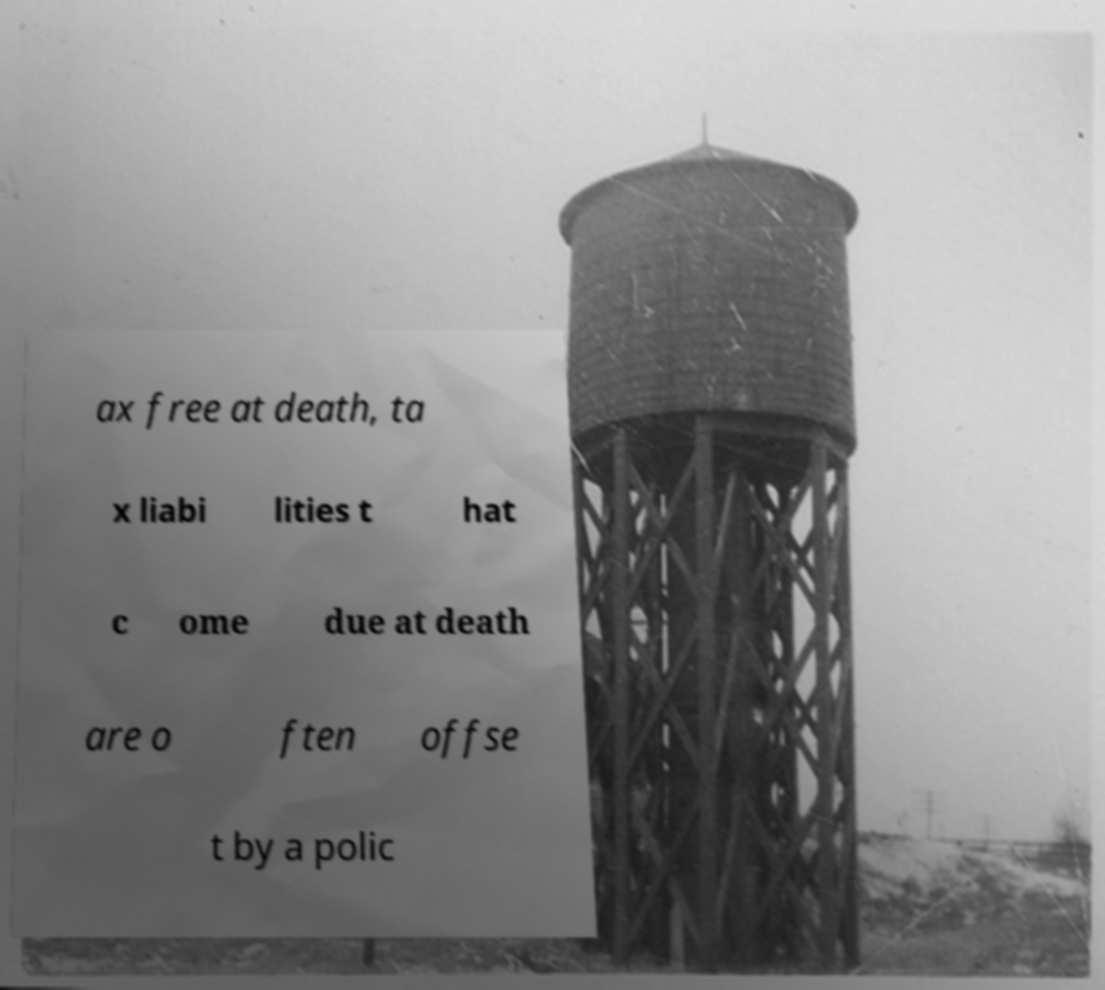For documentation purposes, I need the text within this image transcribed. Could you provide that? ax free at death, ta x liabi lities t hat c ome due at death are o ften offse t by a polic 